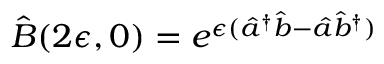Convert formula to latex. <formula><loc_0><loc_0><loc_500><loc_500>\hat { B } ( 2 \epsilon , 0 ) = e ^ { \epsilon ( \hat { a } ^ { \dag } \hat { b } - \hat { a } \hat { b } ^ { \dag } ) }</formula> 